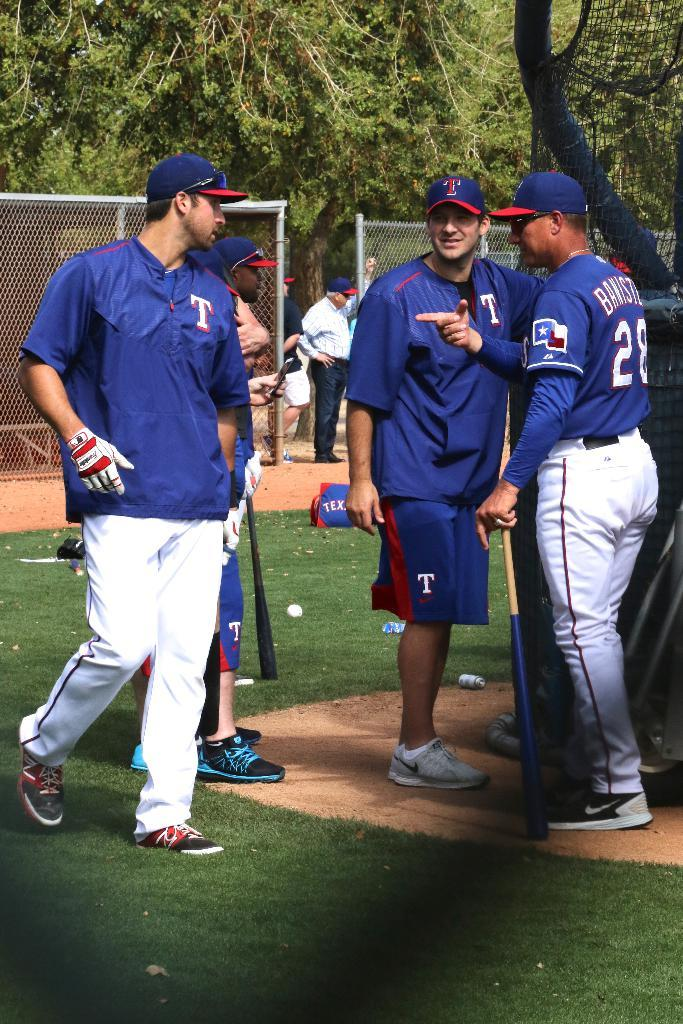<image>
Write a terse but informative summary of the picture. Baseball players wearing warm ups with T on them talk to player number 28. 